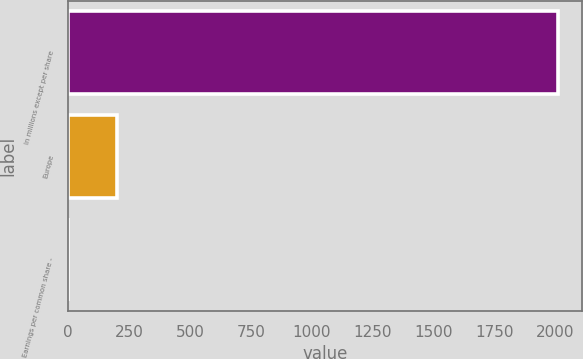<chart> <loc_0><loc_0><loc_500><loc_500><bar_chart><fcel>In millions except per share<fcel>Europe<fcel>Earnings per common share -<nl><fcel>2009<fcel>200.97<fcel>0.08<nl></chart> 